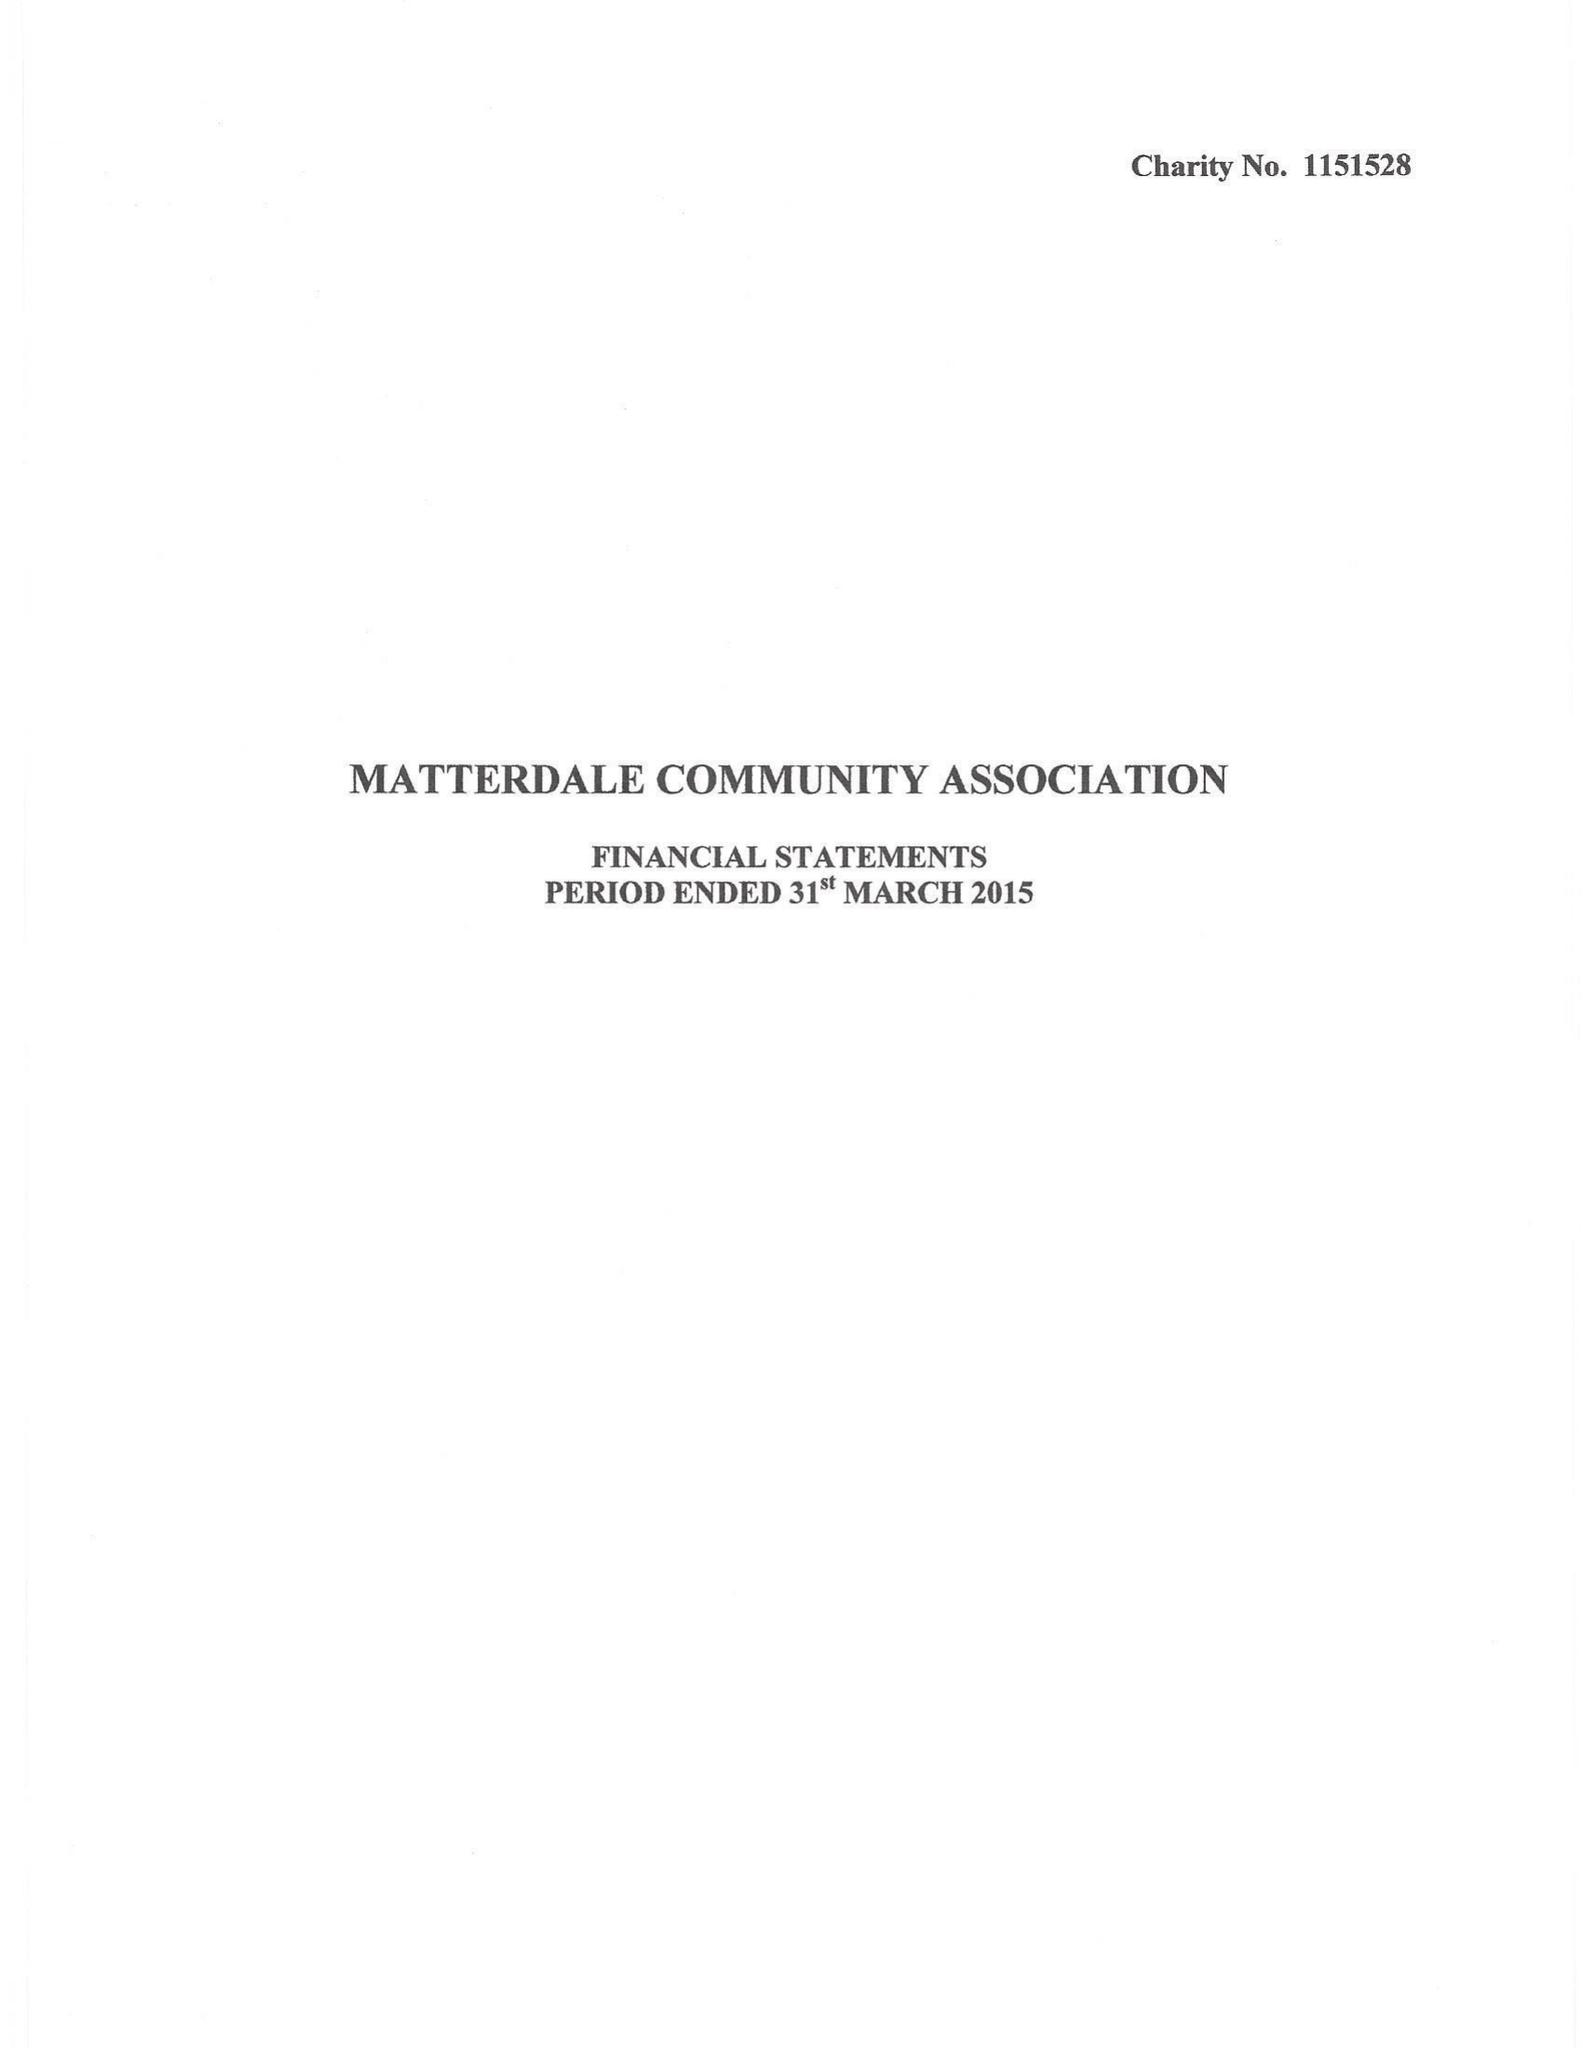What is the value for the address__postcode?
Answer the question using a single word or phrase. CA11 0LD 